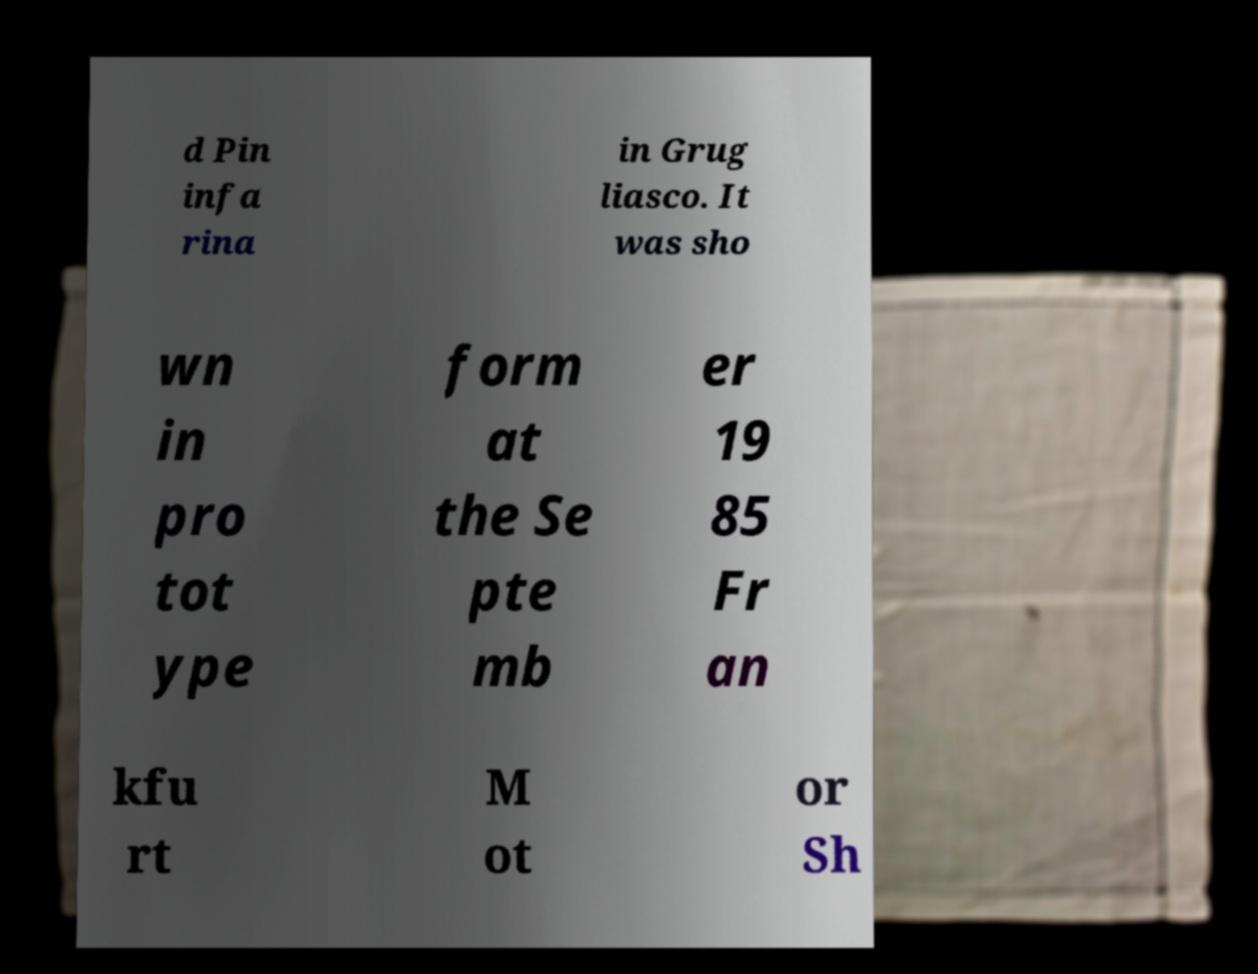What messages or text are displayed in this image? I need them in a readable, typed format. d Pin infa rina in Grug liasco. It was sho wn in pro tot ype form at the Se pte mb er 19 85 Fr an kfu rt M ot or Sh 